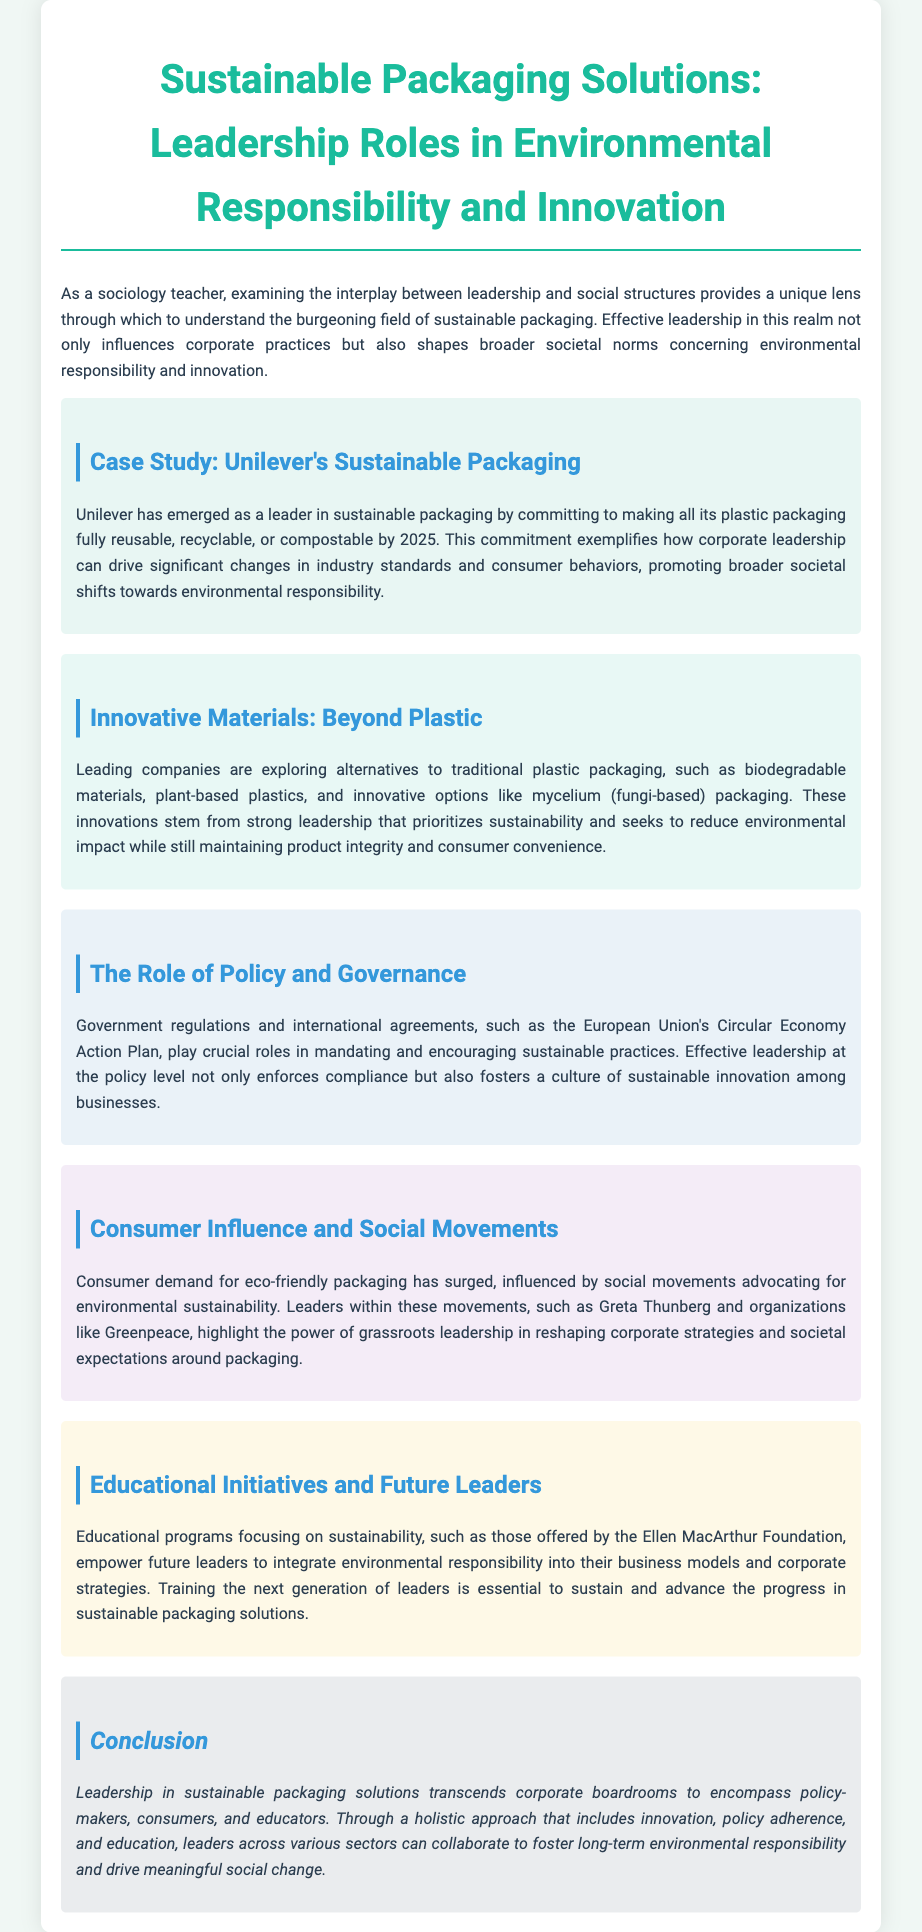What is Unilever's commitment for its plastic packaging? Unilever aims to make all its plastic packaging fully reusable, recyclable, or compostable by 2025.
Answer: by 2025 What innovative material alternatives are mentioned? The document discusses biodegradable materials, plant-based plastics, and mycelium packaging as alternatives to traditional plastic.
Answer: biodegradable materials, plant-based plastics, mycelium What governance initiative is referenced in the document? The European Union's Circular Economy Action Plan is a key policy referenced regarding sustainable practices.
Answer: Circular Economy Action Plan Who highlighted the power of grassroots leadership in sustainability? Greta Thunberg is specifically mentioned as a leader influencing corporate strategies and societal expectations.
Answer: Greta Thunberg What educational organization is mentioned for empowering future leaders? The Ellen MacArthur Foundation provides educational programs focusing on sustainability.
Answer: Ellen MacArthur Foundation How does the document classify leadership roles? Leadership roles are classified into corporate, policy-making, consumer advocacy, and educational sectors regarding sustainable packaging.
Answer: corporate, policy-making, consumer advocacy, educational What year is significant for Unilever's sustainable packaging initiative? The significant year for Unilever's commitment is 2025.
Answer: 2025 What type of packaging do strong leaders in corporations prioritize? Leaders prioritize sustainability in packaging solutions.
Answer: sustainability 